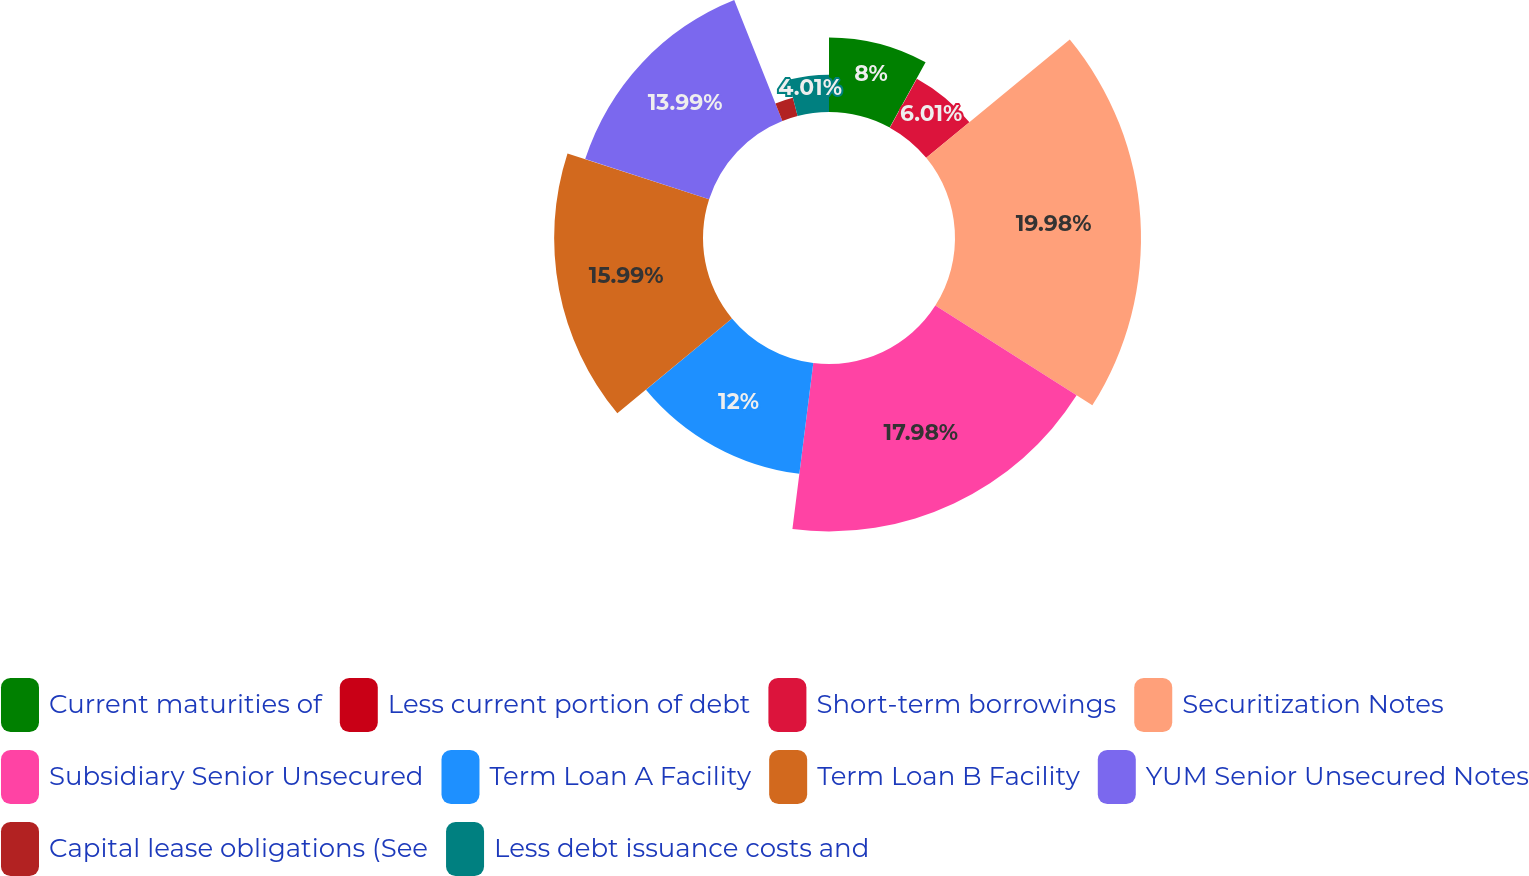Convert chart to OTSL. <chart><loc_0><loc_0><loc_500><loc_500><pie_chart><fcel>Current maturities of<fcel>Less current portion of debt<fcel>Short-term borrowings<fcel>Securitization Notes<fcel>Subsidiary Senior Unsecured<fcel>Term Loan A Facility<fcel>Term Loan B Facility<fcel>YUM Senior Unsecured Notes<fcel>Capital lease obligations (See<fcel>Less debt issuance costs and<nl><fcel>8.0%<fcel>0.02%<fcel>6.01%<fcel>19.98%<fcel>17.98%<fcel>12.0%<fcel>15.99%<fcel>13.99%<fcel>2.02%<fcel>4.01%<nl></chart> 